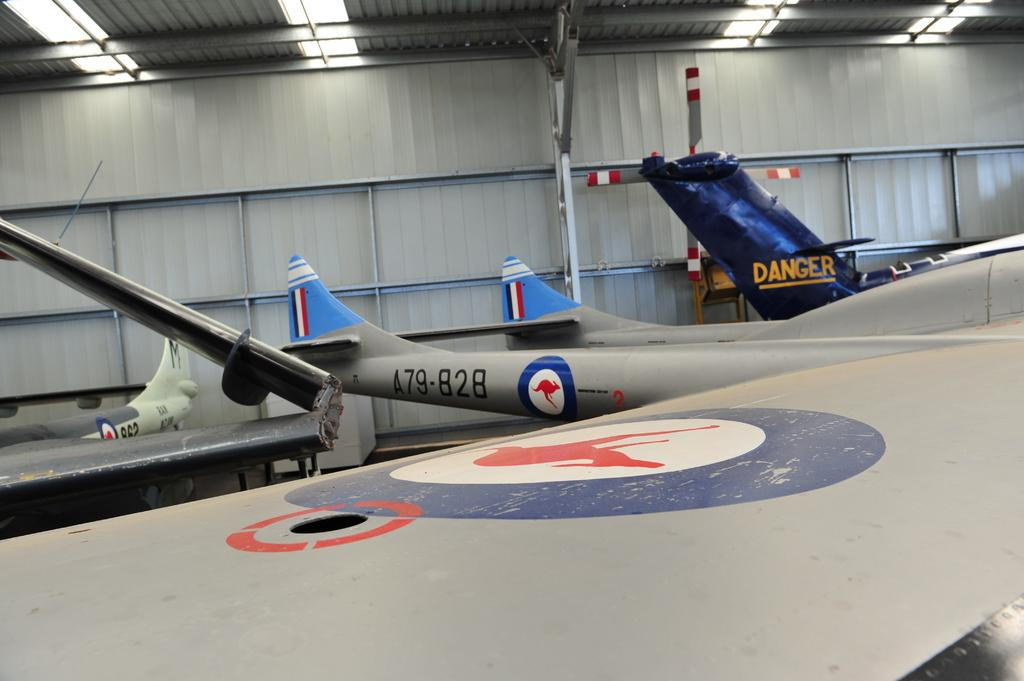What is the main subject of the image? The main subject of the image is a wing of an aircraft. Can you describe the surroundings of the aircraft wing? There are other aircrafts visible in the background, and there is a wall in the background of the image. What type of lighting is present in the background? There are lights on the ceiling in the background. What type of cheese is being used to repair the aircraft wing in the image? There is no cheese present in the image, and the aircraft wing does not appear to be in need of repair. 